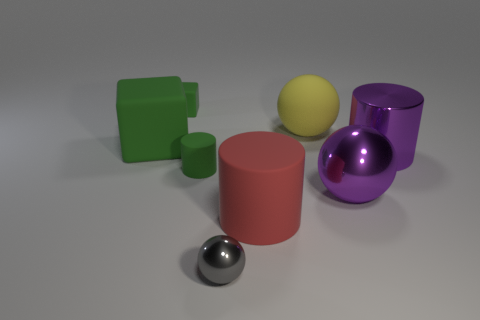There is a cube that is behind the yellow matte sphere; is its color the same as the big matte block?
Offer a terse response. Yes. The tiny green thing that is to the right of the green rubber block behind the large yellow ball is what shape?
Offer a very short reply. Cylinder. What number of things are green rubber things that are behind the large red rubber cylinder or things that are in front of the big red thing?
Give a very brief answer. 4. The red object that is the same material as the large block is what shape?
Your answer should be very brief. Cylinder. Is there any other thing that is the same color as the small cylinder?
Offer a very short reply. Yes. What is the material of the other large thing that is the same shape as the yellow rubber object?
Offer a very short reply. Metal. How many other things are the same size as the yellow matte object?
Your answer should be compact. 4. What is the red cylinder made of?
Your answer should be very brief. Rubber. Are there more green objects to the right of the purple cylinder than large yellow rubber objects?
Make the answer very short. No. Are any red matte cylinders visible?
Your response must be concise. Yes. 